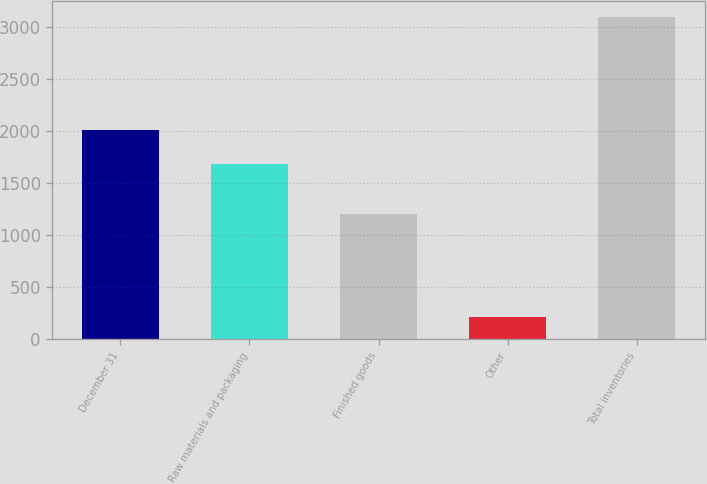Convert chart. <chart><loc_0><loc_0><loc_500><loc_500><bar_chart><fcel>December 31<fcel>Raw materials and packaging<fcel>Finished goods<fcel>Other<fcel>Total inventories<nl><fcel>2011<fcel>1680<fcel>1198<fcel>214<fcel>3092<nl></chart> 